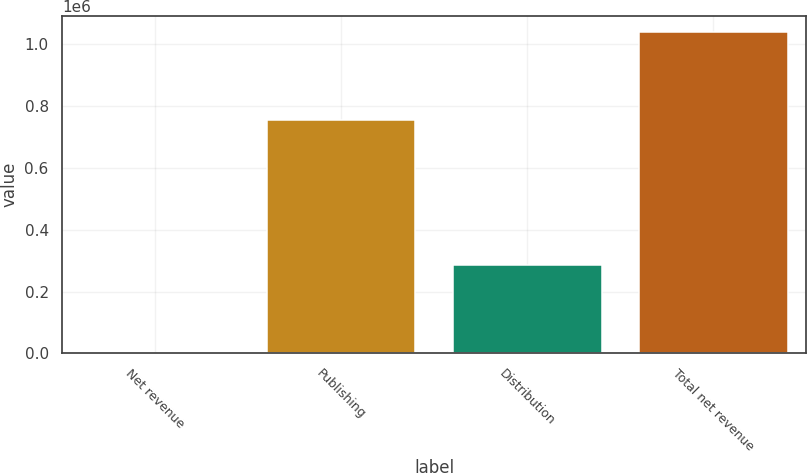<chart> <loc_0><loc_0><loc_500><loc_500><bar_chart><fcel>Net revenue<fcel>Publishing<fcel>Distribution<fcel>Total net revenue<nl><fcel>2006<fcel>753315<fcel>284525<fcel>1.03784e+06<nl></chart> 